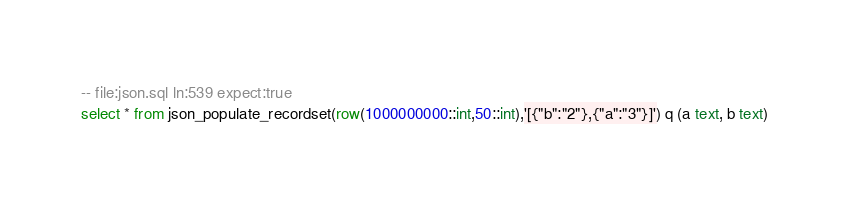<code> <loc_0><loc_0><loc_500><loc_500><_SQL_>-- file:json.sql ln:539 expect:true
select * from json_populate_recordset(row(1000000000::int,50::int),'[{"b":"2"},{"a":"3"}]') q (a text, b text)
</code> 